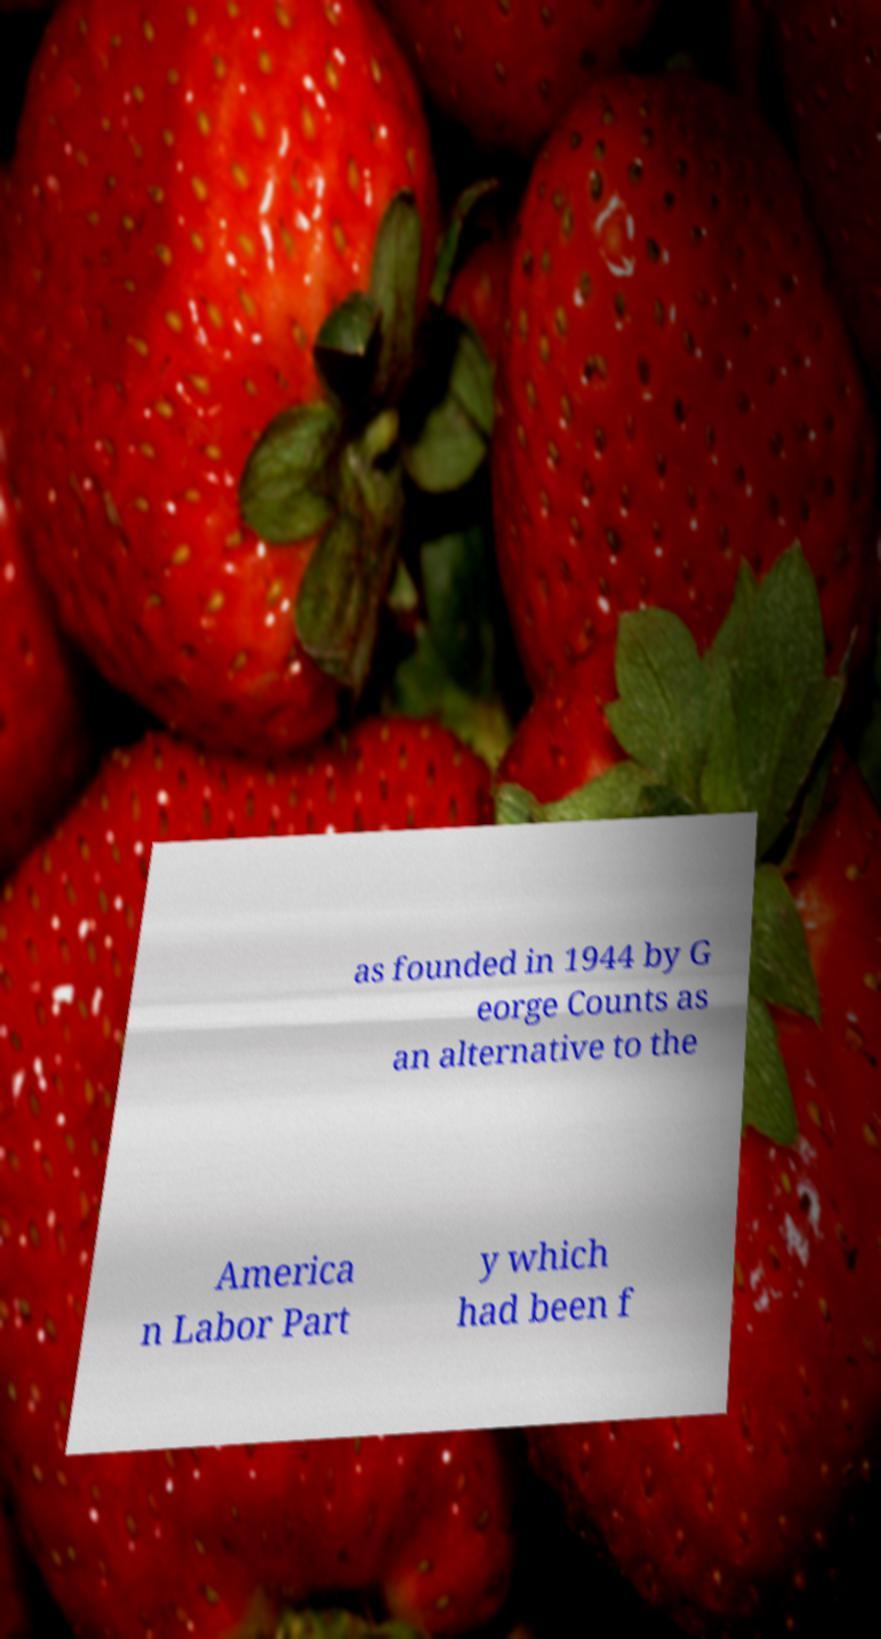There's text embedded in this image that I need extracted. Can you transcribe it verbatim? as founded in 1944 by G eorge Counts as an alternative to the America n Labor Part y which had been f 